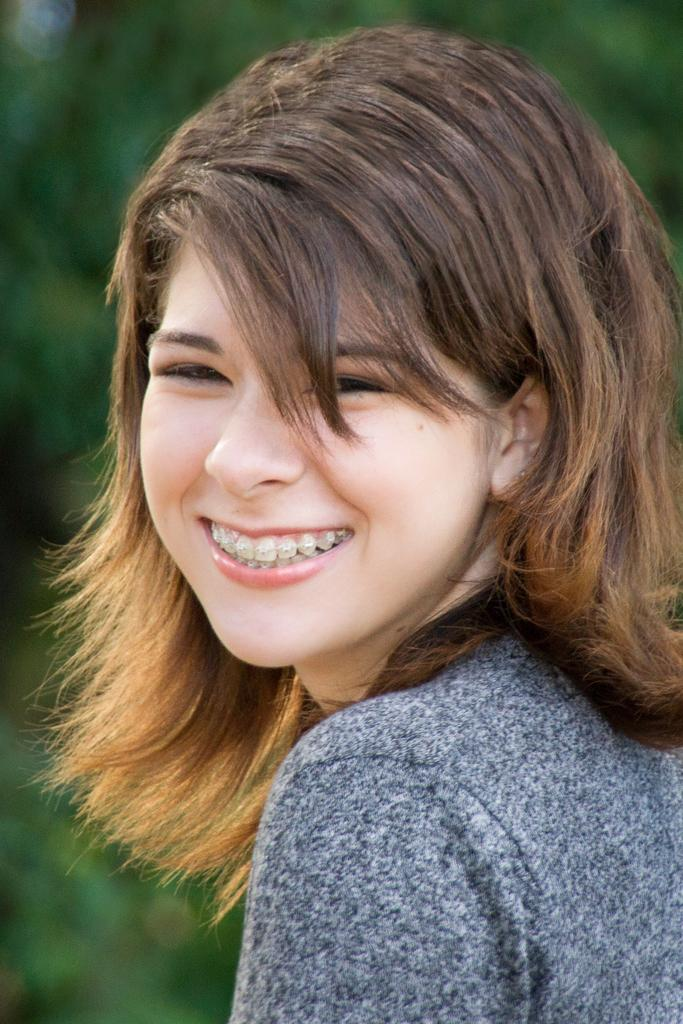Who is present in the image? There is a woman in the image. What is the woman doing in the image? The woman is smiling in the image. What is the woman wearing in the image? The woman is wearing a grey dress in the image. What type of butter is being used in the class that the woman is attending in the image? There is no class or butter present in the image; it only features a woman wearing a grey dress and smiling. 